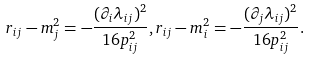Convert formula to latex. <formula><loc_0><loc_0><loc_500><loc_500>r _ { i j } - m _ { j } ^ { 2 } = - \frac { ( \partial _ { i } \lambda _ { i j } ) ^ { 2 } } { 1 6 p _ { i j } ^ { 2 } } , r _ { i j } - m _ { i } ^ { 2 } = - \frac { ( \partial _ { j } \lambda _ { i j } ) ^ { 2 } } { 1 6 p _ { i j } ^ { 2 } } .</formula> 